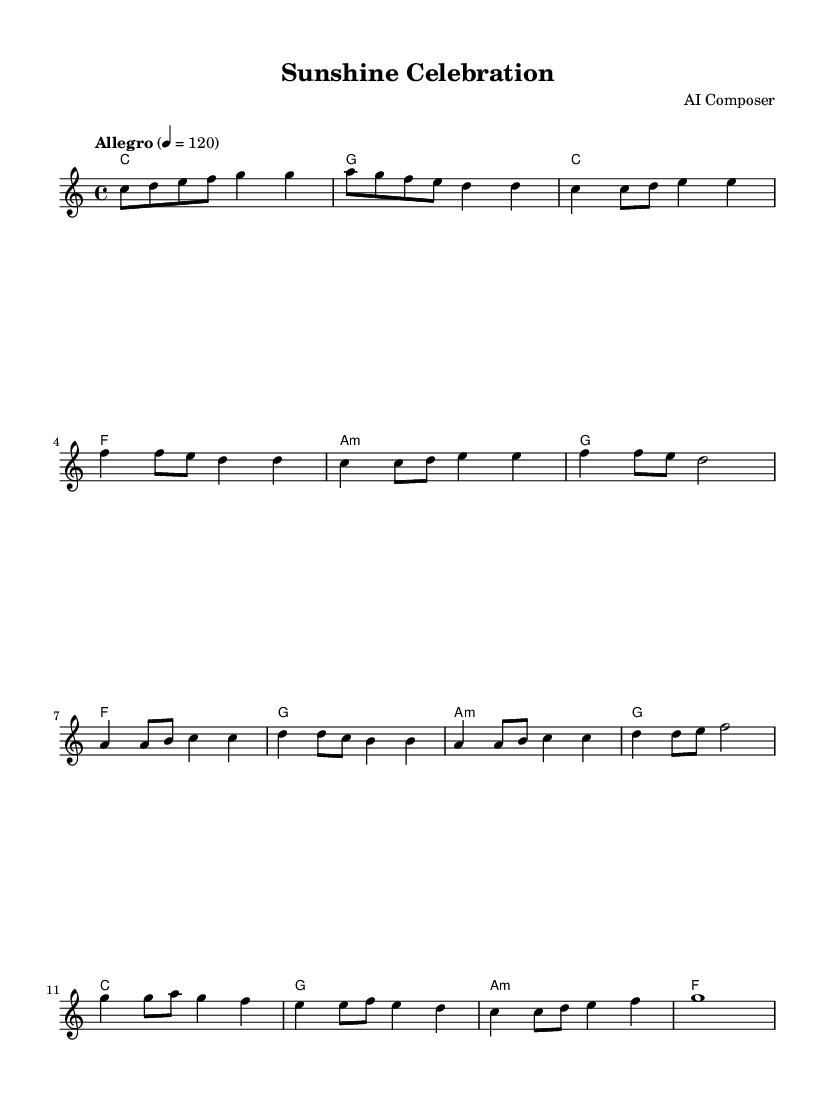What is the key signature of this music? The key signature is C major, which has no sharps or flats.
Answer: C major What is the time signature of this music? The time signature is indicated as 4/4, meaning there are four beats in a measure and a quarter note receives one beat.
Answer: 4/4 What is the tempo marking of this piece? The tempo marking "Allegro" indicates a fast tempo, and the number 120 means there are 120 beats per minute.
Answer: Allegro 4 = 120 What is the starting note of the melody? The first note of the melody is C, as shown at the beginning of the melody line.
Answer: C How many measures are there in the chorus section? By analyzing the sheet music, the chorus section consists of 4 measures, which can be counted directly in the score.
Answer: 4 What is the final chord in the piece? The final chord in the piece can be found at the end of the score, which shows a C major chord.
Answer: C How many different sections are there in this piece? The score can be divided into four distinct sections: Intro, Verse, Pre-chorus, and Chorus.
Answer: 4 